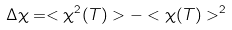<formula> <loc_0><loc_0><loc_500><loc_500>\Delta \chi = < \chi ^ { 2 } ( T ) > - < \chi ( T ) > ^ { 2 }</formula> 